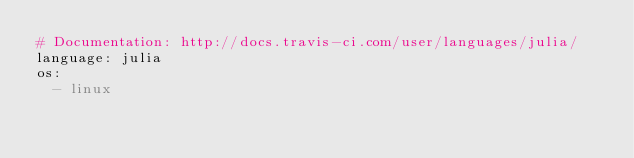Convert code to text. <code><loc_0><loc_0><loc_500><loc_500><_YAML_># Documentation: http://docs.travis-ci.com/user/languages/julia/
language: julia
os:
  - linux</code> 